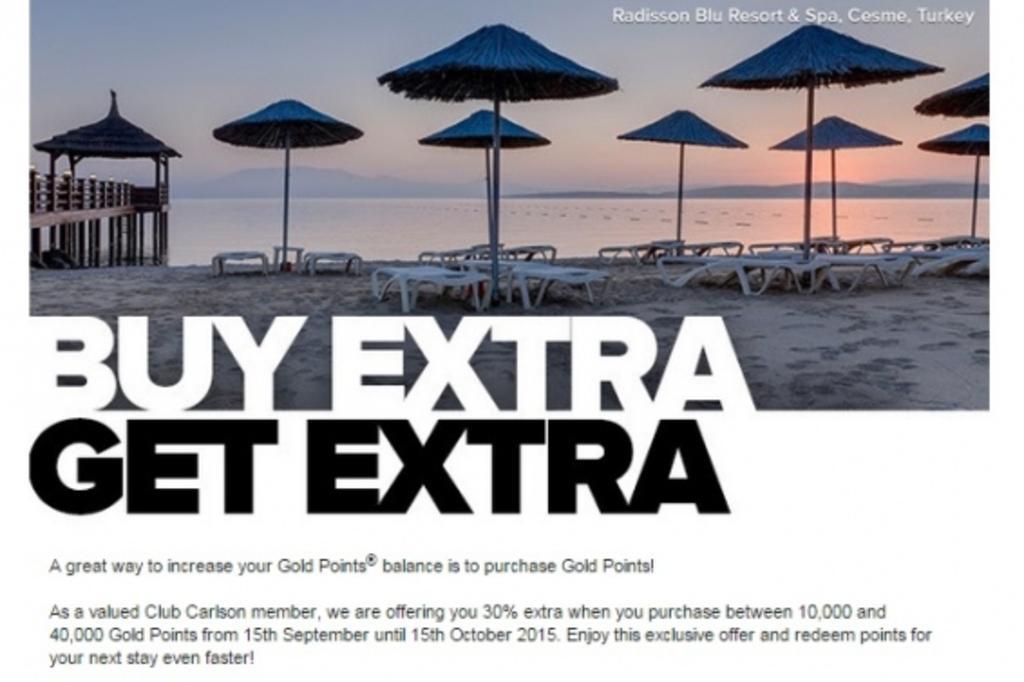Describe this image in one or two sentences. In this image there are shacks on the beach sand, in front of the shacks there is water and mountains and there is some text written. 